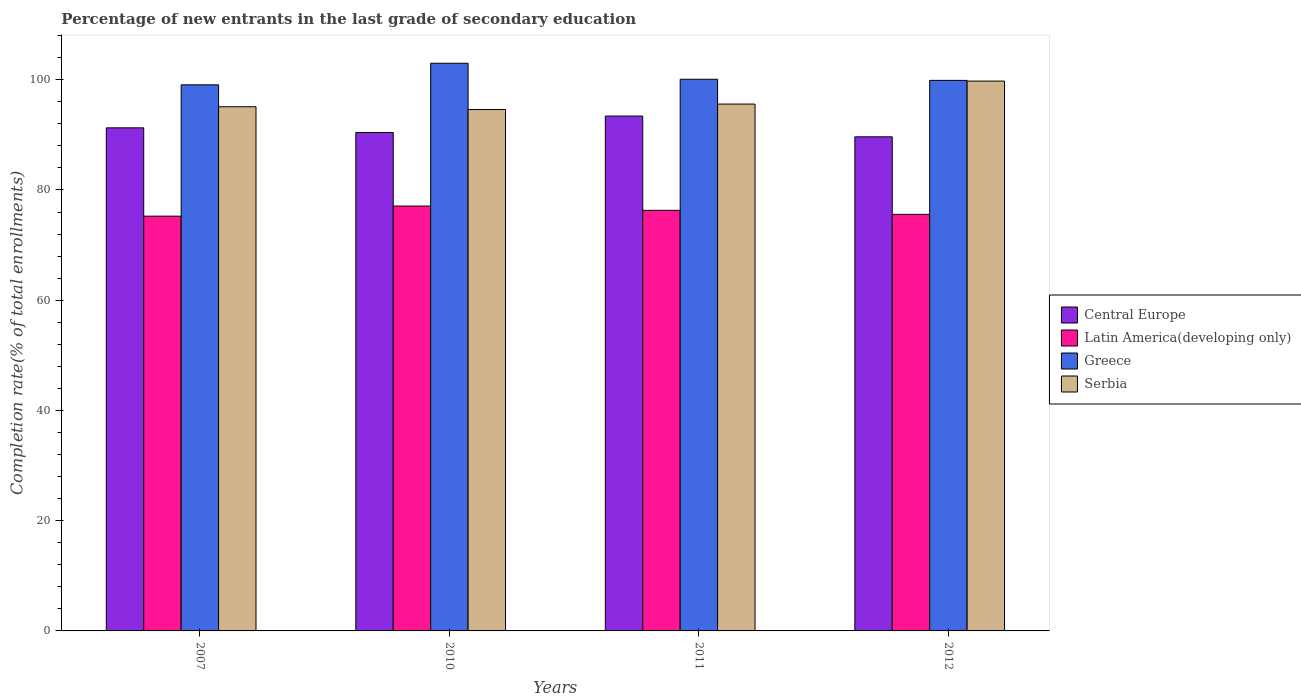How many different coloured bars are there?
Your answer should be compact. 4. How many groups of bars are there?
Provide a short and direct response. 4. Are the number of bars on each tick of the X-axis equal?
Your response must be concise. Yes. How many bars are there on the 4th tick from the left?
Your answer should be compact. 4. How many bars are there on the 3rd tick from the right?
Offer a terse response. 4. In how many cases, is the number of bars for a given year not equal to the number of legend labels?
Offer a terse response. 0. What is the percentage of new entrants in Central Europe in 2007?
Give a very brief answer. 91.28. Across all years, what is the maximum percentage of new entrants in Central Europe?
Give a very brief answer. 93.41. Across all years, what is the minimum percentage of new entrants in Greece?
Offer a very short reply. 99.08. In which year was the percentage of new entrants in Serbia minimum?
Provide a succinct answer. 2010. What is the total percentage of new entrants in Central Europe in the graph?
Ensure brevity in your answer.  364.76. What is the difference between the percentage of new entrants in Serbia in 2007 and that in 2011?
Provide a short and direct response. -0.49. What is the difference between the percentage of new entrants in Serbia in 2007 and the percentage of new entrants in Latin America(developing only) in 2010?
Offer a terse response. 18.01. What is the average percentage of new entrants in Serbia per year?
Offer a very short reply. 96.26. In the year 2011, what is the difference between the percentage of new entrants in Latin America(developing only) and percentage of new entrants in Greece?
Provide a short and direct response. -23.78. In how many years, is the percentage of new entrants in Serbia greater than 76 %?
Provide a succinct answer. 4. What is the ratio of the percentage of new entrants in Greece in 2011 to that in 2012?
Make the answer very short. 1. Is the percentage of new entrants in Central Europe in 2011 less than that in 2012?
Provide a short and direct response. No. What is the difference between the highest and the second highest percentage of new entrants in Serbia?
Offer a very short reply. 4.17. What is the difference between the highest and the lowest percentage of new entrants in Serbia?
Make the answer very short. 5.16. In how many years, is the percentage of new entrants in Greece greater than the average percentage of new entrants in Greece taken over all years?
Offer a terse response. 1. Is the sum of the percentage of new entrants in Central Europe in 2010 and 2011 greater than the maximum percentage of new entrants in Latin America(developing only) across all years?
Provide a succinct answer. Yes. Is it the case that in every year, the sum of the percentage of new entrants in Central Europe and percentage of new entrants in Greece is greater than the sum of percentage of new entrants in Latin America(developing only) and percentage of new entrants in Serbia?
Provide a short and direct response. No. What does the 1st bar from the left in 2011 represents?
Your answer should be compact. Central Europe. What does the 4th bar from the right in 2010 represents?
Keep it short and to the point. Central Europe. Are the values on the major ticks of Y-axis written in scientific E-notation?
Provide a succinct answer. No. Does the graph contain any zero values?
Make the answer very short. No. Does the graph contain grids?
Keep it short and to the point. No. How many legend labels are there?
Make the answer very short. 4. How are the legend labels stacked?
Ensure brevity in your answer.  Vertical. What is the title of the graph?
Your answer should be compact. Percentage of new entrants in the last grade of secondary education. Does "European Union" appear as one of the legend labels in the graph?
Keep it short and to the point. No. What is the label or title of the Y-axis?
Keep it short and to the point. Completion rate(% of total enrollments). What is the Completion rate(% of total enrollments) in Central Europe in 2007?
Provide a short and direct response. 91.28. What is the Completion rate(% of total enrollments) of Latin America(developing only) in 2007?
Keep it short and to the point. 75.25. What is the Completion rate(% of total enrollments) of Greece in 2007?
Your response must be concise. 99.08. What is the Completion rate(% of total enrollments) of Serbia in 2007?
Your answer should be compact. 95.1. What is the Completion rate(% of total enrollments) of Central Europe in 2010?
Keep it short and to the point. 90.43. What is the Completion rate(% of total enrollments) in Latin America(developing only) in 2010?
Your answer should be very brief. 77.09. What is the Completion rate(% of total enrollments) of Greece in 2010?
Offer a terse response. 102.99. What is the Completion rate(% of total enrollments) in Serbia in 2010?
Keep it short and to the point. 94.6. What is the Completion rate(% of total enrollments) in Central Europe in 2011?
Give a very brief answer. 93.41. What is the Completion rate(% of total enrollments) in Latin America(developing only) in 2011?
Keep it short and to the point. 76.31. What is the Completion rate(% of total enrollments) in Greece in 2011?
Provide a short and direct response. 100.09. What is the Completion rate(% of total enrollments) of Serbia in 2011?
Offer a very short reply. 95.59. What is the Completion rate(% of total enrollments) of Central Europe in 2012?
Provide a succinct answer. 89.65. What is the Completion rate(% of total enrollments) of Latin America(developing only) in 2012?
Provide a short and direct response. 75.58. What is the Completion rate(% of total enrollments) in Greece in 2012?
Provide a succinct answer. 99.88. What is the Completion rate(% of total enrollments) in Serbia in 2012?
Keep it short and to the point. 99.76. Across all years, what is the maximum Completion rate(% of total enrollments) in Central Europe?
Your answer should be very brief. 93.41. Across all years, what is the maximum Completion rate(% of total enrollments) of Latin America(developing only)?
Your answer should be compact. 77.09. Across all years, what is the maximum Completion rate(% of total enrollments) of Greece?
Your answer should be compact. 102.99. Across all years, what is the maximum Completion rate(% of total enrollments) in Serbia?
Your response must be concise. 99.76. Across all years, what is the minimum Completion rate(% of total enrollments) of Central Europe?
Offer a terse response. 89.65. Across all years, what is the minimum Completion rate(% of total enrollments) of Latin America(developing only)?
Keep it short and to the point. 75.25. Across all years, what is the minimum Completion rate(% of total enrollments) of Greece?
Your response must be concise. 99.08. Across all years, what is the minimum Completion rate(% of total enrollments) in Serbia?
Your response must be concise. 94.6. What is the total Completion rate(% of total enrollments) of Central Europe in the graph?
Your answer should be very brief. 364.76. What is the total Completion rate(% of total enrollments) in Latin America(developing only) in the graph?
Provide a short and direct response. 304.23. What is the total Completion rate(% of total enrollments) in Greece in the graph?
Keep it short and to the point. 402.04. What is the total Completion rate(% of total enrollments) in Serbia in the graph?
Offer a very short reply. 385.05. What is the difference between the Completion rate(% of total enrollments) of Central Europe in 2007 and that in 2010?
Ensure brevity in your answer.  0.85. What is the difference between the Completion rate(% of total enrollments) in Latin America(developing only) in 2007 and that in 2010?
Provide a succinct answer. -1.84. What is the difference between the Completion rate(% of total enrollments) of Greece in 2007 and that in 2010?
Ensure brevity in your answer.  -3.92. What is the difference between the Completion rate(% of total enrollments) of Serbia in 2007 and that in 2010?
Ensure brevity in your answer.  0.5. What is the difference between the Completion rate(% of total enrollments) in Central Europe in 2007 and that in 2011?
Give a very brief answer. -2.13. What is the difference between the Completion rate(% of total enrollments) in Latin America(developing only) in 2007 and that in 2011?
Ensure brevity in your answer.  -1.06. What is the difference between the Completion rate(% of total enrollments) of Greece in 2007 and that in 2011?
Your answer should be compact. -1.01. What is the difference between the Completion rate(% of total enrollments) in Serbia in 2007 and that in 2011?
Keep it short and to the point. -0.49. What is the difference between the Completion rate(% of total enrollments) of Central Europe in 2007 and that in 2012?
Offer a terse response. 1.63. What is the difference between the Completion rate(% of total enrollments) of Latin America(developing only) in 2007 and that in 2012?
Provide a short and direct response. -0.33. What is the difference between the Completion rate(% of total enrollments) of Greece in 2007 and that in 2012?
Provide a succinct answer. -0.81. What is the difference between the Completion rate(% of total enrollments) of Serbia in 2007 and that in 2012?
Ensure brevity in your answer.  -4.66. What is the difference between the Completion rate(% of total enrollments) of Central Europe in 2010 and that in 2011?
Ensure brevity in your answer.  -2.99. What is the difference between the Completion rate(% of total enrollments) of Latin America(developing only) in 2010 and that in 2011?
Your response must be concise. 0.78. What is the difference between the Completion rate(% of total enrollments) of Greece in 2010 and that in 2011?
Make the answer very short. 2.9. What is the difference between the Completion rate(% of total enrollments) in Serbia in 2010 and that in 2011?
Your answer should be compact. -0.99. What is the difference between the Completion rate(% of total enrollments) in Central Europe in 2010 and that in 2012?
Your answer should be compact. 0.78. What is the difference between the Completion rate(% of total enrollments) of Latin America(developing only) in 2010 and that in 2012?
Provide a short and direct response. 1.51. What is the difference between the Completion rate(% of total enrollments) of Greece in 2010 and that in 2012?
Your answer should be compact. 3.11. What is the difference between the Completion rate(% of total enrollments) of Serbia in 2010 and that in 2012?
Make the answer very short. -5.16. What is the difference between the Completion rate(% of total enrollments) in Central Europe in 2011 and that in 2012?
Your answer should be very brief. 3.76. What is the difference between the Completion rate(% of total enrollments) of Latin America(developing only) in 2011 and that in 2012?
Your answer should be very brief. 0.73. What is the difference between the Completion rate(% of total enrollments) in Greece in 2011 and that in 2012?
Make the answer very short. 0.2. What is the difference between the Completion rate(% of total enrollments) in Serbia in 2011 and that in 2012?
Your response must be concise. -4.17. What is the difference between the Completion rate(% of total enrollments) in Central Europe in 2007 and the Completion rate(% of total enrollments) in Latin America(developing only) in 2010?
Keep it short and to the point. 14.19. What is the difference between the Completion rate(% of total enrollments) of Central Europe in 2007 and the Completion rate(% of total enrollments) of Greece in 2010?
Offer a terse response. -11.72. What is the difference between the Completion rate(% of total enrollments) of Central Europe in 2007 and the Completion rate(% of total enrollments) of Serbia in 2010?
Provide a short and direct response. -3.32. What is the difference between the Completion rate(% of total enrollments) of Latin America(developing only) in 2007 and the Completion rate(% of total enrollments) of Greece in 2010?
Offer a very short reply. -27.74. What is the difference between the Completion rate(% of total enrollments) in Latin America(developing only) in 2007 and the Completion rate(% of total enrollments) in Serbia in 2010?
Give a very brief answer. -19.35. What is the difference between the Completion rate(% of total enrollments) in Greece in 2007 and the Completion rate(% of total enrollments) in Serbia in 2010?
Provide a succinct answer. 4.48. What is the difference between the Completion rate(% of total enrollments) of Central Europe in 2007 and the Completion rate(% of total enrollments) of Latin America(developing only) in 2011?
Your answer should be very brief. 14.97. What is the difference between the Completion rate(% of total enrollments) in Central Europe in 2007 and the Completion rate(% of total enrollments) in Greece in 2011?
Make the answer very short. -8.81. What is the difference between the Completion rate(% of total enrollments) in Central Europe in 2007 and the Completion rate(% of total enrollments) in Serbia in 2011?
Give a very brief answer. -4.31. What is the difference between the Completion rate(% of total enrollments) in Latin America(developing only) in 2007 and the Completion rate(% of total enrollments) in Greece in 2011?
Keep it short and to the point. -24.84. What is the difference between the Completion rate(% of total enrollments) in Latin America(developing only) in 2007 and the Completion rate(% of total enrollments) in Serbia in 2011?
Provide a succinct answer. -20.34. What is the difference between the Completion rate(% of total enrollments) of Greece in 2007 and the Completion rate(% of total enrollments) of Serbia in 2011?
Keep it short and to the point. 3.49. What is the difference between the Completion rate(% of total enrollments) in Central Europe in 2007 and the Completion rate(% of total enrollments) in Latin America(developing only) in 2012?
Your answer should be very brief. 15.7. What is the difference between the Completion rate(% of total enrollments) in Central Europe in 2007 and the Completion rate(% of total enrollments) in Greece in 2012?
Give a very brief answer. -8.61. What is the difference between the Completion rate(% of total enrollments) of Central Europe in 2007 and the Completion rate(% of total enrollments) of Serbia in 2012?
Make the answer very short. -8.48. What is the difference between the Completion rate(% of total enrollments) in Latin America(developing only) in 2007 and the Completion rate(% of total enrollments) in Greece in 2012?
Make the answer very short. -24.64. What is the difference between the Completion rate(% of total enrollments) in Latin America(developing only) in 2007 and the Completion rate(% of total enrollments) in Serbia in 2012?
Provide a succinct answer. -24.51. What is the difference between the Completion rate(% of total enrollments) in Greece in 2007 and the Completion rate(% of total enrollments) in Serbia in 2012?
Provide a short and direct response. -0.68. What is the difference between the Completion rate(% of total enrollments) in Central Europe in 2010 and the Completion rate(% of total enrollments) in Latin America(developing only) in 2011?
Provide a succinct answer. 14.12. What is the difference between the Completion rate(% of total enrollments) in Central Europe in 2010 and the Completion rate(% of total enrollments) in Greece in 2011?
Keep it short and to the point. -9.66. What is the difference between the Completion rate(% of total enrollments) of Central Europe in 2010 and the Completion rate(% of total enrollments) of Serbia in 2011?
Make the answer very short. -5.16. What is the difference between the Completion rate(% of total enrollments) in Latin America(developing only) in 2010 and the Completion rate(% of total enrollments) in Greece in 2011?
Provide a short and direct response. -23. What is the difference between the Completion rate(% of total enrollments) of Latin America(developing only) in 2010 and the Completion rate(% of total enrollments) of Serbia in 2011?
Offer a terse response. -18.5. What is the difference between the Completion rate(% of total enrollments) of Greece in 2010 and the Completion rate(% of total enrollments) of Serbia in 2011?
Offer a very short reply. 7.4. What is the difference between the Completion rate(% of total enrollments) in Central Europe in 2010 and the Completion rate(% of total enrollments) in Latin America(developing only) in 2012?
Offer a terse response. 14.85. What is the difference between the Completion rate(% of total enrollments) of Central Europe in 2010 and the Completion rate(% of total enrollments) of Greece in 2012?
Offer a terse response. -9.46. What is the difference between the Completion rate(% of total enrollments) of Central Europe in 2010 and the Completion rate(% of total enrollments) of Serbia in 2012?
Provide a short and direct response. -9.33. What is the difference between the Completion rate(% of total enrollments) of Latin America(developing only) in 2010 and the Completion rate(% of total enrollments) of Greece in 2012?
Ensure brevity in your answer.  -22.8. What is the difference between the Completion rate(% of total enrollments) of Latin America(developing only) in 2010 and the Completion rate(% of total enrollments) of Serbia in 2012?
Offer a terse response. -22.67. What is the difference between the Completion rate(% of total enrollments) in Greece in 2010 and the Completion rate(% of total enrollments) in Serbia in 2012?
Make the answer very short. 3.23. What is the difference between the Completion rate(% of total enrollments) of Central Europe in 2011 and the Completion rate(% of total enrollments) of Latin America(developing only) in 2012?
Your response must be concise. 17.83. What is the difference between the Completion rate(% of total enrollments) in Central Europe in 2011 and the Completion rate(% of total enrollments) in Greece in 2012?
Offer a terse response. -6.47. What is the difference between the Completion rate(% of total enrollments) in Central Europe in 2011 and the Completion rate(% of total enrollments) in Serbia in 2012?
Offer a very short reply. -6.35. What is the difference between the Completion rate(% of total enrollments) in Latin America(developing only) in 2011 and the Completion rate(% of total enrollments) in Greece in 2012?
Your answer should be very brief. -23.57. What is the difference between the Completion rate(% of total enrollments) of Latin America(developing only) in 2011 and the Completion rate(% of total enrollments) of Serbia in 2012?
Your answer should be very brief. -23.45. What is the difference between the Completion rate(% of total enrollments) of Greece in 2011 and the Completion rate(% of total enrollments) of Serbia in 2012?
Your response must be concise. 0.33. What is the average Completion rate(% of total enrollments) in Central Europe per year?
Keep it short and to the point. 91.19. What is the average Completion rate(% of total enrollments) of Latin America(developing only) per year?
Provide a short and direct response. 76.06. What is the average Completion rate(% of total enrollments) in Greece per year?
Make the answer very short. 100.51. What is the average Completion rate(% of total enrollments) in Serbia per year?
Offer a terse response. 96.26. In the year 2007, what is the difference between the Completion rate(% of total enrollments) in Central Europe and Completion rate(% of total enrollments) in Latin America(developing only)?
Your answer should be compact. 16.03. In the year 2007, what is the difference between the Completion rate(% of total enrollments) in Central Europe and Completion rate(% of total enrollments) in Greece?
Ensure brevity in your answer.  -7.8. In the year 2007, what is the difference between the Completion rate(% of total enrollments) of Central Europe and Completion rate(% of total enrollments) of Serbia?
Your answer should be very brief. -3.82. In the year 2007, what is the difference between the Completion rate(% of total enrollments) of Latin America(developing only) and Completion rate(% of total enrollments) of Greece?
Provide a succinct answer. -23.83. In the year 2007, what is the difference between the Completion rate(% of total enrollments) of Latin America(developing only) and Completion rate(% of total enrollments) of Serbia?
Your answer should be compact. -19.85. In the year 2007, what is the difference between the Completion rate(% of total enrollments) of Greece and Completion rate(% of total enrollments) of Serbia?
Provide a succinct answer. 3.98. In the year 2010, what is the difference between the Completion rate(% of total enrollments) in Central Europe and Completion rate(% of total enrollments) in Latin America(developing only)?
Offer a very short reply. 13.34. In the year 2010, what is the difference between the Completion rate(% of total enrollments) of Central Europe and Completion rate(% of total enrollments) of Greece?
Offer a terse response. -12.57. In the year 2010, what is the difference between the Completion rate(% of total enrollments) in Central Europe and Completion rate(% of total enrollments) in Serbia?
Offer a very short reply. -4.17. In the year 2010, what is the difference between the Completion rate(% of total enrollments) in Latin America(developing only) and Completion rate(% of total enrollments) in Greece?
Your response must be concise. -25.9. In the year 2010, what is the difference between the Completion rate(% of total enrollments) in Latin America(developing only) and Completion rate(% of total enrollments) in Serbia?
Your answer should be very brief. -17.51. In the year 2010, what is the difference between the Completion rate(% of total enrollments) of Greece and Completion rate(% of total enrollments) of Serbia?
Your response must be concise. 8.39. In the year 2011, what is the difference between the Completion rate(% of total enrollments) of Central Europe and Completion rate(% of total enrollments) of Latin America(developing only)?
Provide a short and direct response. 17.1. In the year 2011, what is the difference between the Completion rate(% of total enrollments) in Central Europe and Completion rate(% of total enrollments) in Greece?
Offer a very short reply. -6.68. In the year 2011, what is the difference between the Completion rate(% of total enrollments) of Central Europe and Completion rate(% of total enrollments) of Serbia?
Ensure brevity in your answer.  -2.18. In the year 2011, what is the difference between the Completion rate(% of total enrollments) of Latin America(developing only) and Completion rate(% of total enrollments) of Greece?
Your response must be concise. -23.78. In the year 2011, what is the difference between the Completion rate(% of total enrollments) of Latin America(developing only) and Completion rate(% of total enrollments) of Serbia?
Give a very brief answer. -19.28. In the year 2011, what is the difference between the Completion rate(% of total enrollments) in Greece and Completion rate(% of total enrollments) in Serbia?
Your response must be concise. 4.5. In the year 2012, what is the difference between the Completion rate(% of total enrollments) of Central Europe and Completion rate(% of total enrollments) of Latin America(developing only)?
Provide a short and direct response. 14.07. In the year 2012, what is the difference between the Completion rate(% of total enrollments) in Central Europe and Completion rate(% of total enrollments) in Greece?
Your response must be concise. -10.24. In the year 2012, what is the difference between the Completion rate(% of total enrollments) in Central Europe and Completion rate(% of total enrollments) in Serbia?
Ensure brevity in your answer.  -10.11. In the year 2012, what is the difference between the Completion rate(% of total enrollments) of Latin America(developing only) and Completion rate(% of total enrollments) of Greece?
Your answer should be compact. -24.3. In the year 2012, what is the difference between the Completion rate(% of total enrollments) in Latin America(developing only) and Completion rate(% of total enrollments) in Serbia?
Your answer should be very brief. -24.18. In the year 2012, what is the difference between the Completion rate(% of total enrollments) in Greece and Completion rate(% of total enrollments) in Serbia?
Provide a short and direct response. 0.13. What is the ratio of the Completion rate(% of total enrollments) in Central Europe in 2007 to that in 2010?
Provide a short and direct response. 1.01. What is the ratio of the Completion rate(% of total enrollments) in Latin America(developing only) in 2007 to that in 2010?
Ensure brevity in your answer.  0.98. What is the ratio of the Completion rate(% of total enrollments) of Greece in 2007 to that in 2010?
Provide a succinct answer. 0.96. What is the ratio of the Completion rate(% of total enrollments) of Central Europe in 2007 to that in 2011?
Provide a short and direct response. 0.98. What is the ratio of the Completion rate(% of total enrollments) of Latin America(developing only) in 2007 to that in 2011?
Offer a terse response. 0.99. What is the ratio of the Completion rate(% of total enrollments) in Serbia in 2007 to that in 2011?
Give a very brief answer. 0.99. What is the ratio of the Completion rate(% of total enrollments) of Central Europe in 2007 to that in 2012?
Provide a short and direct response. 1.02. What is the ratio of the Completion rate(% of total enrollments) of Latin America(developing only) in 2007 to that in 2012?
Provide a short and direct response. 1. What is the ratio of the Completion rate(% of total enrollments) of Serbia in 2007 to that in 2012?
Your response must be concise. 0.95. What is the ratio of the Completion rate(% of total enrollments) of Central Europe in 2010 to that in 2011?
Your response must be concise. 0.97. What is the ratio of the Completion rate(% of total enrollments) in Latin America(developing only) in 2010 to that in 2011?
Your response must be concise. 1.01. What is the ratio of the Completion rate(% of total enrollments) of Greece in 2010 to that in 2011?
Make the answer very short. 1.03. What is the ratio of the Completion rate(% of total enrollments) of Serbia in 2010 to that in 2011?
Your response must be concise. 0.99. What is the ratio of the Completion rate(% of total enrollments) of Central Europe in 2010 to that in 2012?
Provide a succinct answer. 1.01. What is the ratio of the Completion rate(% of total enrollments) in Latin America(developing only) in 2010 to that in 2012?
Your answer should be compact. 1.02. What is the ratio of the Completion rate(% of total enrollments) of Greece in 2010 to that in 2012?
Your answer should be very brief. 1.03. What is the ratio of the Completion rate(% of total enrollments) in Serbia in 2010 to that in 2012?
Keep it short and to the point. 0.95. What is the ratio of the Completion rate(% of total enrollments) of Central Europe in 2011 to that in 2012?
Offer a very short reply. 1.04. What is the ratio of the Completion rate(% of total enrollments) of Latin America(developing only) in 2011 to that in 2012?
Your answer should be very brief. 1.01. What is the ratio of the Completion rate(% of total enrollments) of Serbia in 2011 to that in 2012?
Ensure brevity in your answer.  0.96. What is the difference between the highest and the second highest Completion rate(% of total enrollments) of Central Europe?
Provide a short and direct response. 2.13. What is the difference between the highest and the second highest Completion rate(% of total enrollments) of Latin America(developing only)?
Make the answer very short. 0.78. What is the difference between the highest and the second highest Completion rate(% of total enrollments) in Greece?
Give a very brief answer. 2.9. What is the difference between the highest and the second highest Completion rate(% of total enrollments) in Serbia?
Offer a very short reply. 4.17. What is the difference between the highest and the lowest Completion rate(% of total enrollments) in Central Europe?
Offer a terse response. 3.76. What is the difference between the highest and the lowest Completion rate(% of total enrollments) in Latin America(developing only)?
Ensure brevity in your answer.  1.84. What is the difference between the highest and the lowest Completion rate(% of total enrollments) in Greece?
Give a very brief answer. 3.92. What is the difference between the highest and the lowest Completion rate(% of total enrollments) of Serbia?
Your response must be concise. 5.16. 